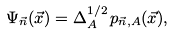<formula> <loc_0><loc_0><loc_500><loc_500>\Psi _ { \vec { n } } ( \vec { x } ) = \Delta _ { A } ^ { 1 / 2 } \, p _ { \vec { n } , A } ( \vec { x } ) ,</formula> 